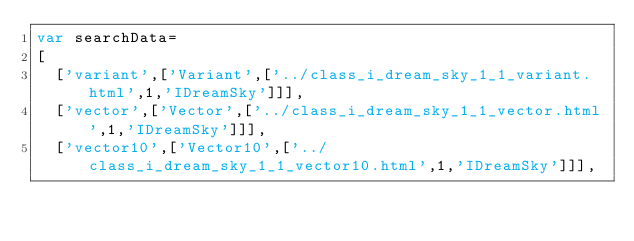Convert code to text. <code><loc_0><loc_0><loc_500><loc_500><_JavaScript_>var searchData=
[
  ['variant',['Variant',['../class_i_dream_sky_1_1_variant.html',1,'IDreamSky']]],
  ['vector',['Vector',['../class_i_dream_sky_1_1_vector.html',1,'IDreamSky']]],
  ['vector10',['Vector10',['../class_i_dream_sky_1_1_vector10.html',1,'IDreamSky']]],</code> 